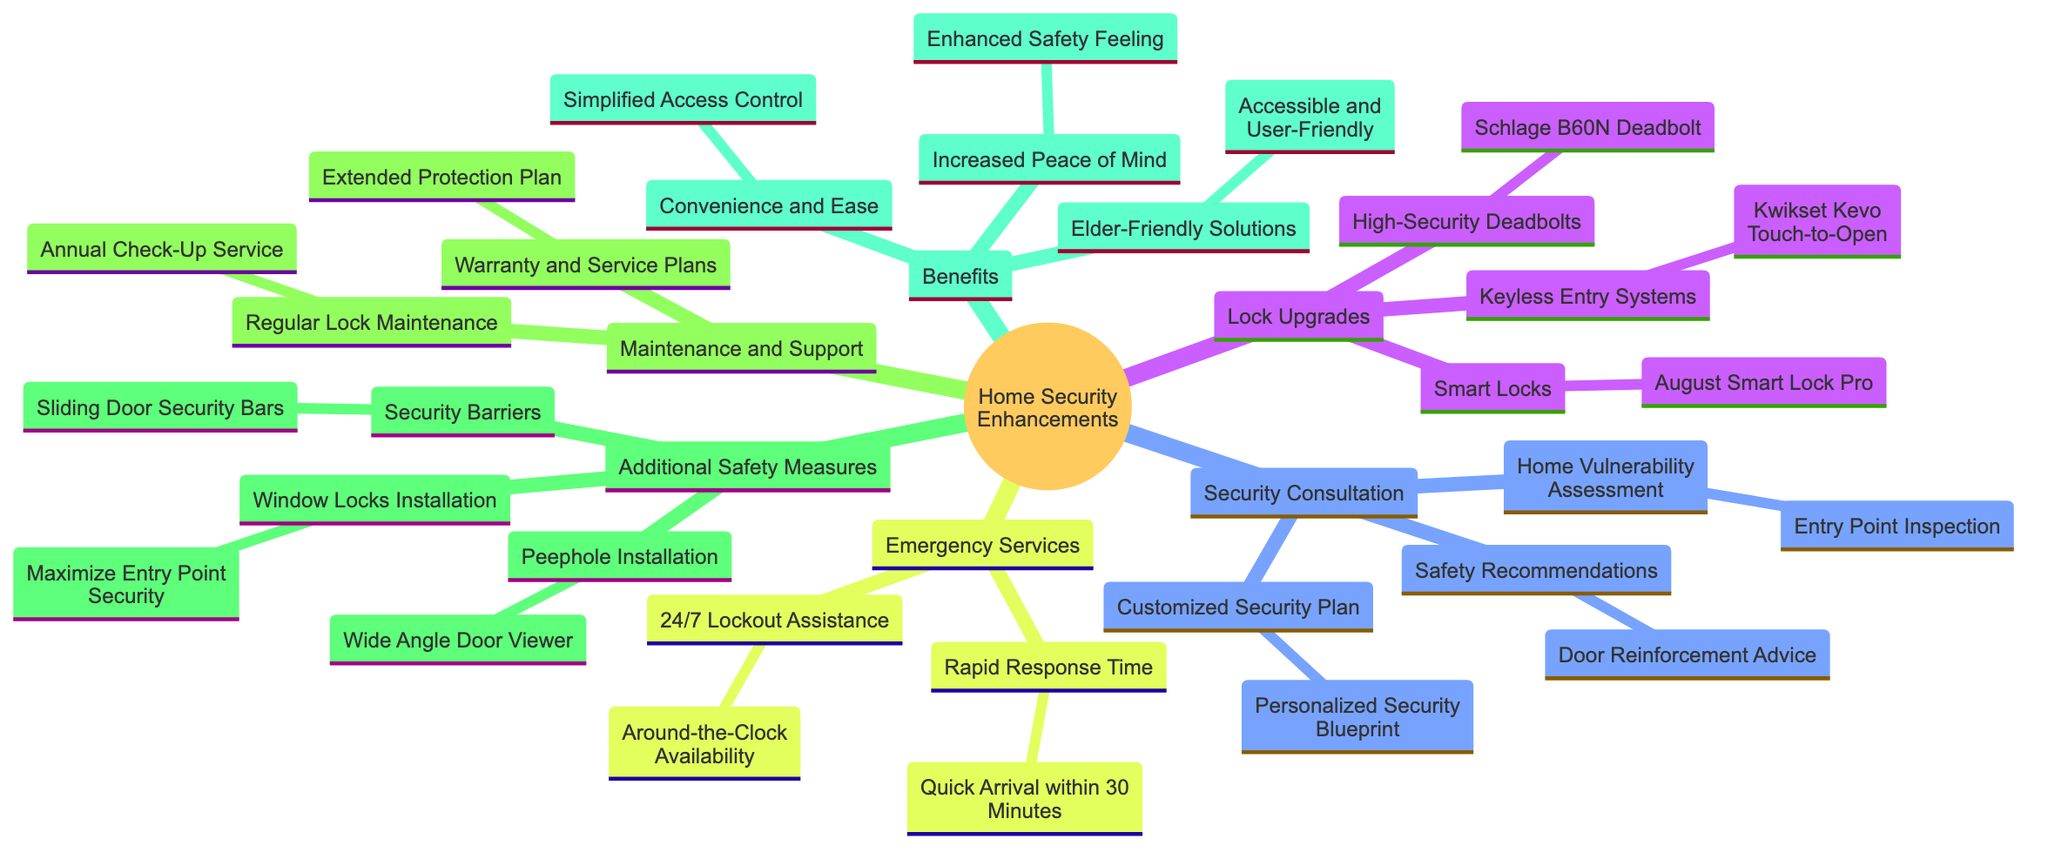What are the types of lock upgrades mentioned? The diagram lists three types of lock upgrades under the "Lock Upgrades" node. They are "High-Security Deadbolts," "Smart Locks," and "Keyless Entry Systems."
Answer: High-Security Deadbolts, Smart Locks, Keyless Entry Systems How many emergency services are outlined in the diagram? There are two main categories under "Emergency Services": "24/7 Lockout Assistance" and "Rapid Response Time," which indicates there are two emergency services listed.
Answer: 2 What is one benefit mentioned for elder-friendly solutions? Under the "Benefits" section, "Elder-Friendly Solutions" points to "Accessible and User-Friendly," which describes the nature of the solutions tailored for elderly homeowners.
Answer: Accessible and User-Friendly Which lock is a smart lock mentioned in the diagram? The "Smart Locks" category specifically names "August Smart Lock Pro," making it the example of a smart lock listed in the document.
Answer: August Smart Lock Pro What type of safety recommendation is provided in the security consultation? The diagram includes "Door Reinforcement Advice" as a safety recommendation under the "Safety Recommendations" node in the "Security Consultation" section.
Answer: Door Reinforcement Advice How quick is the response time for emergency services according to the diagram? The diagram specifies "Quick Arrival within 30 Minutes" under the "Rapid Response Time" node as the measured response time for emergency locksmith services.
Answer: Quick Arrival within 30 Minutes What additional safety measure is suggested for windows? The "Additional Safety Measures" node shows "Window Locks Installation" as one of the safety enhancements suggested for improving home security regarding windows.
Answer: Window Locks Installation What is one measure that enhances peace of mind? The "Increased Peace of Mind" category under "Benefits" signifies that it contributes to an "Enhanced Safety Feeling," leading to greater reassurance and comfort in the security of the home.
Answer: Enhanced Safety Feeling 